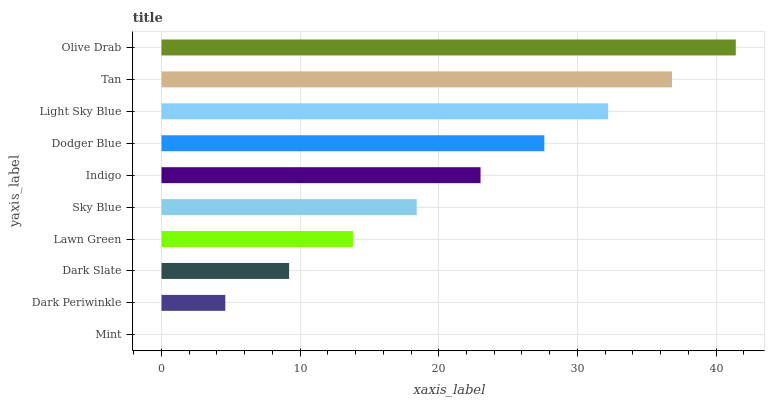Is Mint the minimum?
Answer yes or no. Yes. Is Olive Drab the maximum?
Answer yes or no. Yes. Is Dark Periwinkle the minimum?
Answer yes or no. No. Is Dark Periwinkle the maximum?
Answer yes or no. No. Is Dark Periwinkle greater than Mint?
Answer yes or no. Yes. Is Mint less than Dark Periwinkle?
Answer yes or no. Yes. Is Mint greater than Dark Periwinkle?
Answer yes or no. No. Is Dark Periwinkle less than Mint?
Answer yes or no. No. Is Indigo the high median?
Answer yes or no. Yes. Is Sky Blue the low median?
Answer yes or no. Yes. Is Mint the high median?
Answer yes or no. No. Is Dodger Blue the low median?
Answer yes or no. No. 